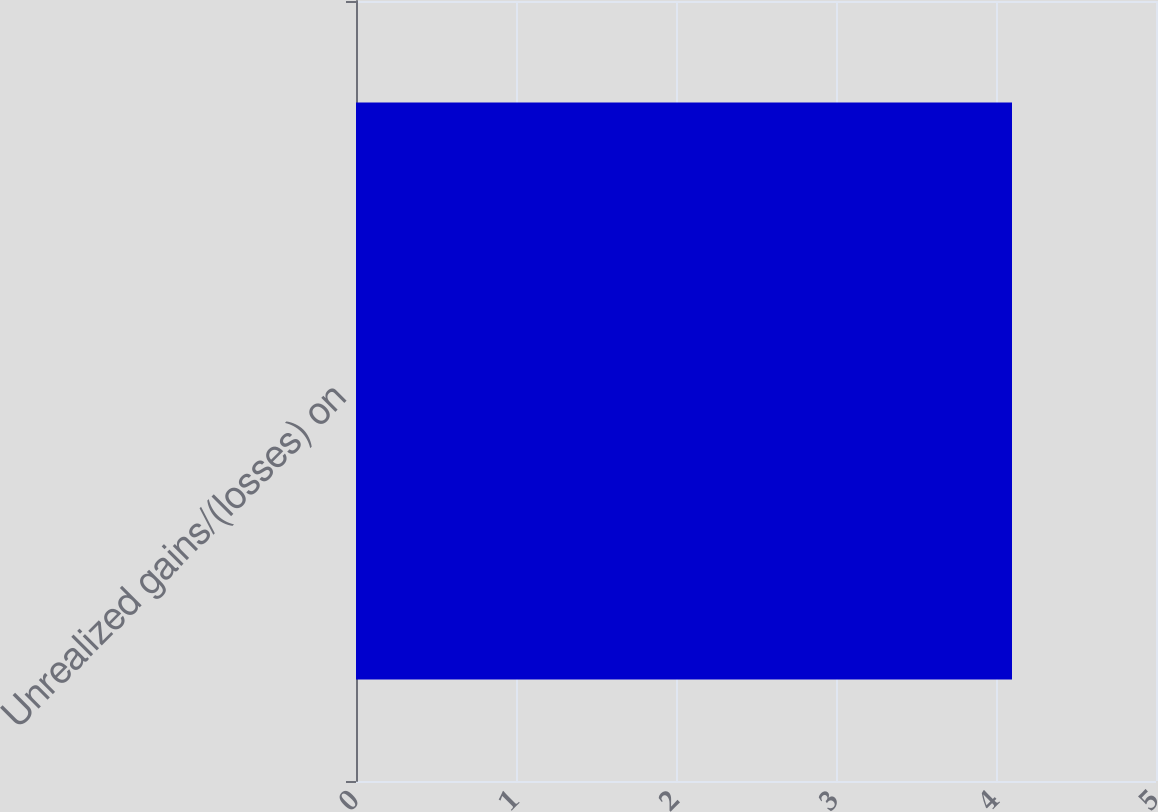Convert chart to OTSL. <chart><loc_0><loc_0><loc_500><loc_500><bar_chart><fcel>Unrealized gains/(losses) on<nl><fcel>4.1<nl></chart> 